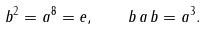Convert formula to latex. <formula><loc_0><loc_0><loc_500><loc_500>b ^ { 2 } = a ^ { 8 } = e , \quad b \, a \, b = a ^ { 3 } .</formula> 